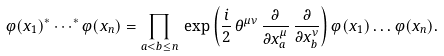Convert formula to latex. <formula><loc_0><loc_0><loc_500><loc_500>\varphi ( x _ { 1 } ) ^ { * } \cdots ^ { * } \varphi ( x _ { n } ) = \prod _ { a < b \leq n } \, \exp { \left ( { \frac { i } { 2 } \, \theta ^ { \mu \nu } \, \frac { \partial } { \partial x ^ { \mu } _ { a } } \, \frac { \partial } { \partial x ^ { \nu } _ { b } } } \right ) } \, \varphi ( x _ { 1 } ) \dots \varphi ( x _ { n } ) .</formula> 